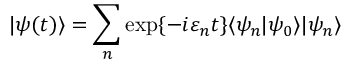<formula> <loc_0><loc_0><loc_500><loc_500>| \psi ( t ) \rangle = \sum _ { n } \exp \{ - i \varepsilon _ { n } t \} \langle \psi _ { n } | \psi _ { 0 } \rangle | \psi _ { n } \rangle</formula> 